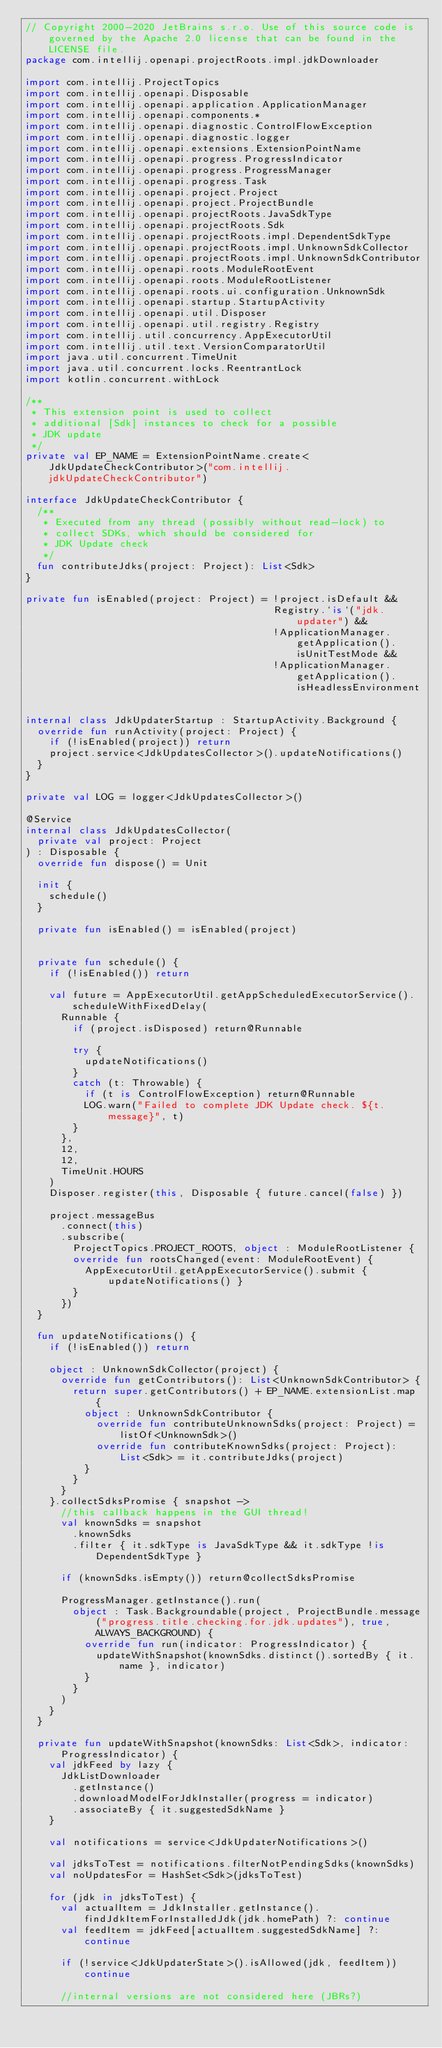<code> <loc_0><loc_0><loc_500><loc_500><_Kotlin_>// Copyright 2000-2020 JetBrains s.r.o. Use of this source code is governed by the Apache 2.0 license that can be found in the LICENSE file.
package com.intellij.openapi.projectRoots.impl.jdkDownloader

import com.intellij.ProjectTopics
import com.intellij.openapi.Disposable
import com.intellij.openapi.application.ApplicationManager
import com.intellij.openapi.components.*
import com.intellij.openapi.diagnostic.ControlFlowException
import com.intellij.openapi.diagnostic.logger
import com.intellij.openapi.extensions.ExtensionPointName
import com.intellij.openapi.progress.ProgressIndicator
import com.intellij.openapi.progress.ProgressManager
import com.intellij.openapi.progress.Task
import com.intellij.openapi.project.Project
import com.intellij.openapi.project.ProjectBundle
import com.intellij.openapi.projectRoots.JavaSdkType
import com.intellij.openapi.projectRoots.Sdk
import com.intellij.openapi.projectRoots.impl.DependentSdkType
import com.intellij.openapi.projectRoots.impl.UnknownSdkCollector
import com.intellij.openapi.projectRoots.impl.UnknownSdkContributor
import com.intellij.openapi.roots.ModuleRootEvent
import com.intellij.openapi.roots.ModuleRootListener
import com.intellij.openapi.roots.ui.configuration.UnknownSdk
import com.intellij.openapi.startup.StartupActivity
import com.intellij.openapi.util.Disposer
import com.intellij.openapi.util.registry.Registry
import com.intellij.util.concurrency.AppExecutorUtil
import com.intellij.util.text.VersionComparatorUtil
import java.util.concurrent.TimeUnit
import java.util.concurrent.locks.ReentrantLock
import kotlin.concurrent.withLock

/**
 * This extension point is used to collect
 * additional [Sdk] instances to check for a possible
 * JDK update
 */
private val EP_NAME = ExtensionPointName.create<JdkUpdateCheckContributor>("com.intellij.jdkUpdateCheckContributor")

interface JdkUpdateCheckContributor {
  /**
   * Executed from any thread (possibly without read-lock) to
   * collect SDKs, which should be considered for
   * JDK Update check
   */
  fun contributeJdks(project: Project): List<Sdk>
}

private fun isEnabled(project: Project) = !project.isDefault &&
                                          Registry.`is`("jdk.updater") &&
                                          !ApplicationManager.getApplication().isUnitTestMode &&
                                          !ApplicationManager.getApplication().isHeadlessEnvironment


internal class JdkUpdaterStartup : StartupActivity.Background {
  override fun runActivity(project: Project) {
    if (!isEnabled(project)) return
    project.service<JdkUpdatesCollector>().updateNotifications()
  }
}

private val LOG = logger<JdkUpdatesCollector>()

@Service
internal class JdkUpdatesCollector(
  private val project: Project
) : Disposable {
  override fun dispose() = Unit

  init {
    schedule()
  }

  private fun isEnabled() = isEnabled(project)


  private fun schedule() {
    if (!isEnabled()) return

    val future = AppExecutorUtil.getAppScheduledExecutorService().scheduleWithFixedDelay(
      Runnable {
        if (project.isDisposed) return@Runnable

        try {
          updateNotifications()
        }
        catch (t: Throwable) {
          if (t is ControlFlowException) return@Runnable
          LOG.warn("Failed to complete JDK Update check. ${t.message}", t)
        }
      },
      12,
      12,
      TimeUnit.HOURS
    )
    Disposer.register(this, Disposable { future.cancel(false) })

    project.messageBus
      .connect(this)
      .subscribe(
        ProjectTopics.PROJECT_ROOTS, object : ModuleRootListener {
        override fun rootsChanged(event: ModuleRootEvent) {
          AppExecutorUtil.getAppExecutorService().submit { updateNotifications() }
        }
      })
  }

  fun updateNotifications() {
    if (!isEnabled()) return

    object : UnknownSdkCollector(project) {
      override fun getContributors(): List<UnknownSdkContributor> {
        return super.getContributors() + EP_NAME.extensionList.map {
          object : UnknownSdkContributor {
            override fun contributeUnknownSdks(project: Project) = listOf<UnknownSdk>()
            override fun contributeKnownSdks(project: Project): List<Sdk> = it.contributeJdks(project)
          }
        }
      }
    }.collectSdksPromise { snapshot ->
      //this callback happens in the GUI thread!
      val knownSdks = snapshot
        .knownSdks
        .filter { it.sdkType is JavaSdkType && it.sdkType !is DependentSdkType }

      if (knownSdks.isEmpty()) return@collectSdksPromise

      ProgressManager.getInstance().run(
        object : Task.Backgroundable(project, ProjectBundle.message("progress.title.checking.for.jdk.updates"), true, ALWAYS_BACKGROUND) {
          override fun run(indicator: ProgressIndicator) {
            updateWithSnapshot(knownSdks.distinct().sortedBy { it.name }, indicator)
          }
        }
      )
    }
  }

  private fun updateWithSnapshot(knownSdks: List<Sdk>, indicator: ProgressIndicator) {
    val jdkFeed by lazy {
      JdkListDownloader
        .getInstance()
        .downloadModelForJdkInstaller(progress = indicator)
        .associateBy { it.suggestedSdkName }
    }

    val notifications = service<JdkUpdaterNotifications>()

    val jdksToTest = notifications.filterNotPendingSdks(knownSdks)
    val noUpdatesFor = HashSet<Sdk>(jdksToTest)

    for (jdk in jdksToTest) {
      val actualItem = JdkInstaller.getInstance().findJdkItemForInstalledJdk(jdk.homePath) ?: continue
      val feedItem = jdkFeed[actualItem.suggestedSdkName] ?: continue

      if (!service<JdkUpdaterState>().isAllowed(jdk, feedItem)) continue

      //internal versions are not considered here (JBRs?)</code> 